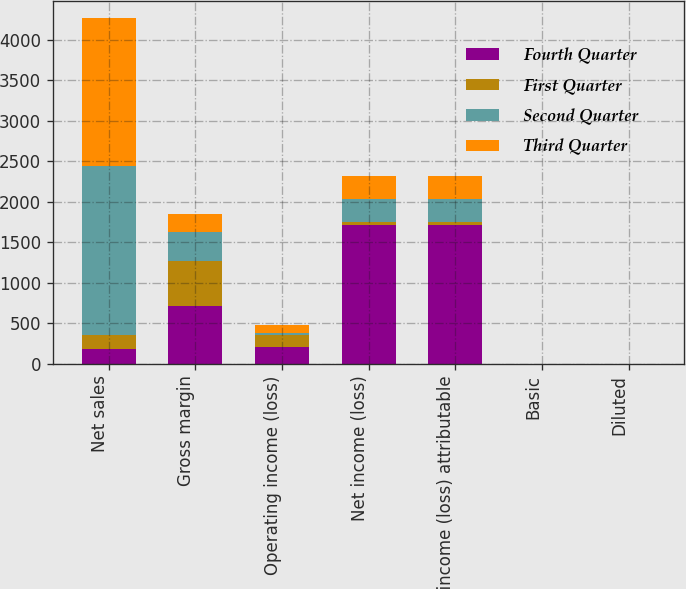<chart> <loc_0><loc_0><loc_500><loc_500><stacked_bar_chart><ecel><fcel>Net sales<fcel>Gross margin<fcel>Operating income (loss)<fcel>Net income (loss)<fcel>Net income (loss) attributable<fcel>Basic<fcel>Diluted<nl><fcel>Fourth Quarter<fcel>178<fcel>708<fcel>207<fcel>1710<fcel>1708<fcel>1.65<fcel>1.51<nl><fcel>First Quarter<fcel>178<fcel>556<fcel>149<fcel>43<fcel>43<fcel>0.04<fcel>0.04<nl><fcel>Second Quarter<fcel>2078<fcel>366<fcel>23<fcel>284<fcel>286<fcel>0.28<fcel>0.28<nl><fcel>Third Quarter<fcel>1834<fcel>217<fcel>97<fcel>275<fcel>275<fcel>0.27<fcel>0.27<nl></chart> 